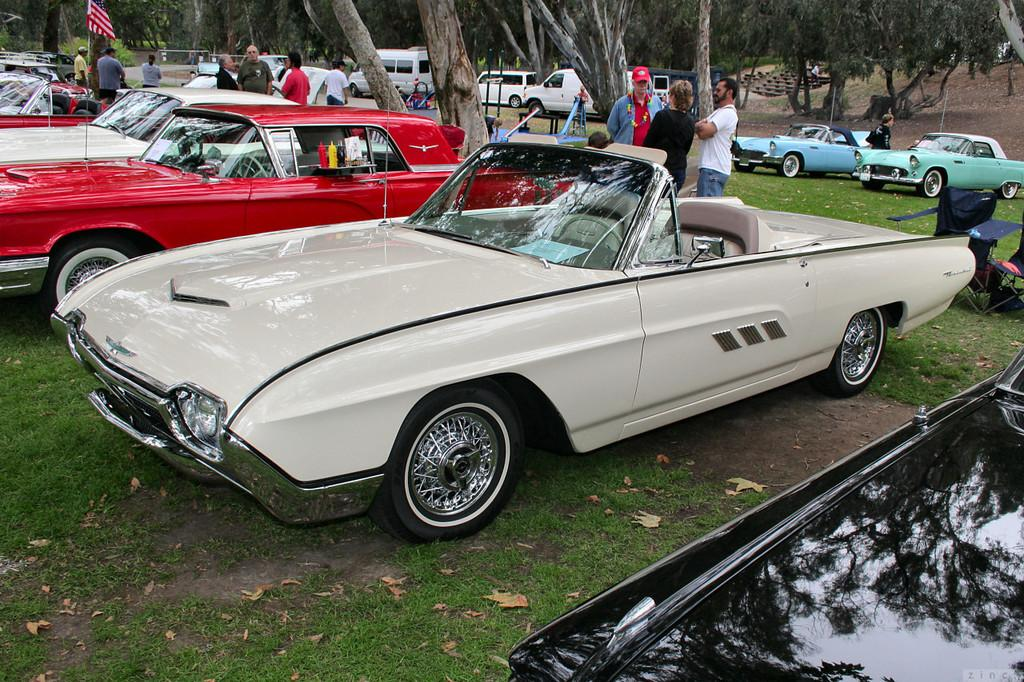Who or what can be seen in the image? There are people in the image. What else is present in the image besides people? There are vehicles, baby trolleys, the ground with grass, trees, dry leaves, a flag, and a pole in the image. What type of picture is hanging on the wall in the image? There is no wall or picture hanging on it in the image. 